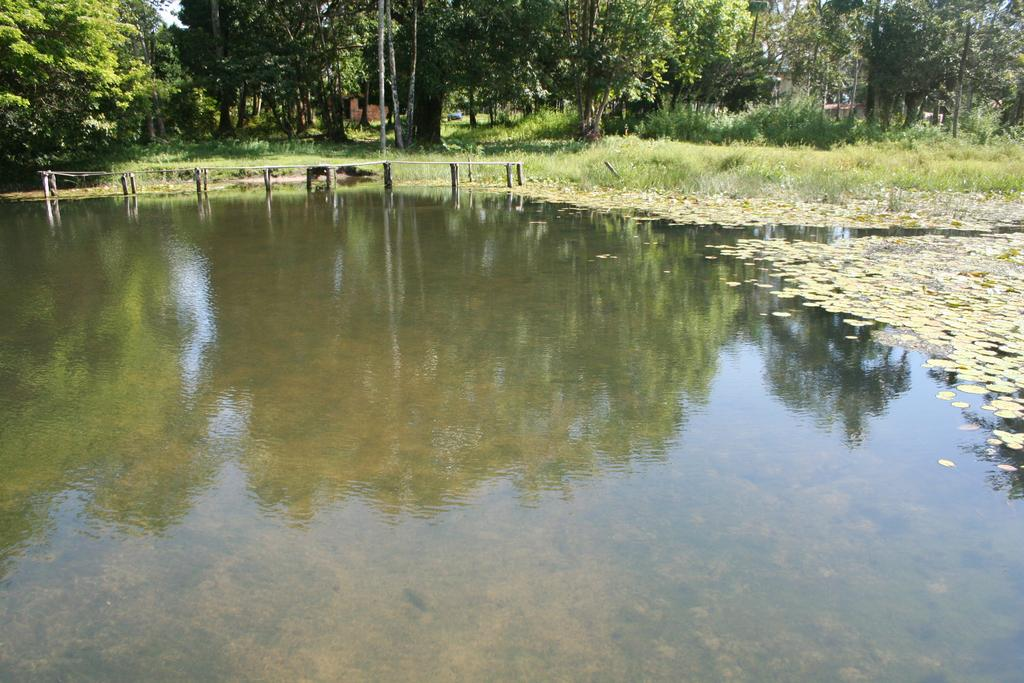What is the main feature of the image? There is water in the image. What type of structure can be seen crossing the water? There is a wooden bridge in the image. What type of vegetation is present in the image? There are trees, plants, and grass in the image. What type of building is visible in the image? There is a house in the image. What can be seen in the sky in the image? The sky is visible in the image. What type of meal is being served on the table in the image? There is no table present in the image, and therefore no meal can be observed. What is the relation between the trees and the wooden bridge in the image? There is no relation mentioned between the trees and the wooden bridge in the image; they are simply two separate features in the image. 